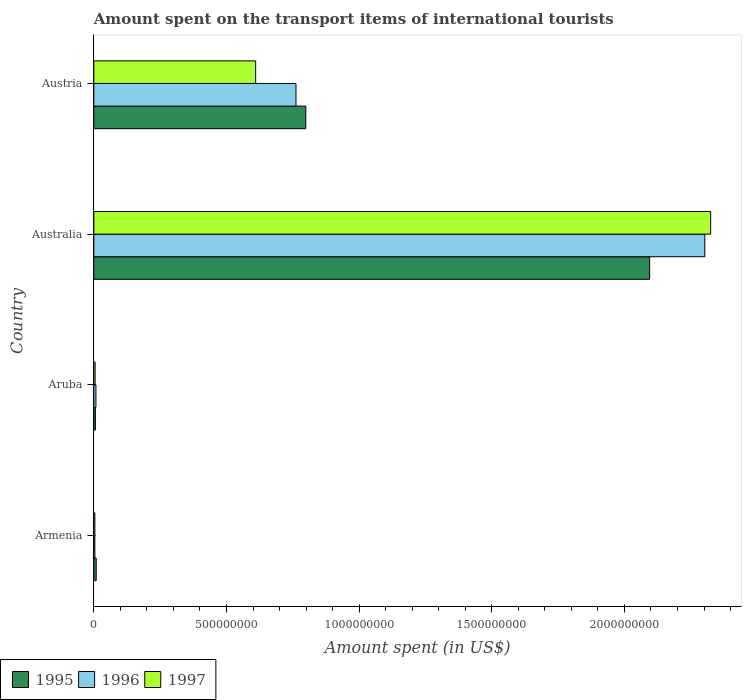How many groups of bars are there?
Keep it short and to the point. 4. Are the number of bars per tick equal to the number of legend labels?
Offer a very short reply. Yes. How many bars are there on the 1st tick from the top?
Provide a succinct answer. 3. How many bars are there on the 3rd tick from the bottom?
Offer a terse response. 3. What is the amount spent on the transport items of international tourists in 1995 in Armenia?
Offer a terse response. 9.00e+06. Across all countries, what is the maximum amount spent on the transport items of international tourists in 1995?
Provide a short and direct response. 2.10e+09. In which country was the amount spent on the transport items of international tourists in 1995 minimum?
Provide a succinct answer. Aruba. What is the total amount spent on the transport items of international tourists in 1997 in the graph?
Ensure brevity in your answer.  2.94e+09. What is the difference between the amount spent on the transport items of international tourists in 1996 in Armenia and that in Australia?
Your response must be concise. -2.30e+09. What is the difference between the amount spent on the transport items of international tourists in 1995 in Armenia and the amount spent on the transport items of international tourists in 1997 in Australia?
Offer a terse response. -2.32e+09. What is the average amount spent on the transport items of international tourists in 1995 per country?
Keep it short and to the point. 7.27e+08. What is the difference between the amount spent on the transport items of international tourists in 1997 and amount spent on the transport items of international tourists in 1995 in Austria?
Provide a short and direct response. -1.89e+08. What is the ratio of the amount spent on the transport items of international tourists in 1996 in Armenia to that in Austria?
Provide a succinct answer. 0.01. Is the amount spent on the transport items of international tourists in 1996 in Armenia less than that in Aruba?
Your answer should be compact. Yes. Is the difference between the amount spent on the transport items of international tourists in 1997 in Aruba and Austria greater than the difference between the amount spent on the transport items of international tourists in 1995 in Aruba and Austria?
Keep it short and to the point. Yes. What is the difference between the highest and the second highest amount spent on the transport items of international tourists in 1996?
Keep it short and to the point. 1.54e+09. What is the difference between the highest and the lowest amount spent on the transport items of international tourists in 1997?
Make the answer very short. 2.32e+09. In how many countries, is the amount spent on the transport items of international tourists in 1995 greater than the average amount spent on the transport items of international tourists in 1995 taken over all countries?
Ensure brevity in your answer.  2. Is the sum of the amount spent on the transport items of international tourists in 1996 in Armenia and Australia greater than the maximum amount spent on the transport items of international tourists in 1995 across all countries?
Keep it short and to the point. Yes. How many bars are there?
Offer a terse response. 12. How many countries are there in the graph?
Keep it short and to the point. 4. What is the difference between two consecutive major ticks on the X-axis?
Your answer should be compact. 5.00e+08. Does the graph contain any zero values?
Keep it short and to the point. No. Does the graph contain grids?
Keep it short and to the point. No. What is the title of the graph?
Keep it short and to the point. Amount spent on the transport items of international tourists. What is the label or title of the X-axis?
Your answer should be compact. Amount spent (in US$). What is the Amount spent (in US$) of 1995 in Armenia?
Your answer should be very brief. 9.00e+06. What is the Amount spent (in US$) in 1996 in Armenia?
Your answer should be very brief. 4.00e+06. What is the Amount spent (in US$) in 1997 in Aruba?
Provide a succinct answer. 5.00e+06. What is the Amount spent (in US$) of 1995 in Australia?
Offer a very short reply. 2.10e+09. What is the Amount spent (in US$) in 1996 in Australia?
Your answer should be very brief. 2.30e+09. What is the Amount spent (in US$) in 1997 in Australia?
Make the answer very short. 2.32e+09. What is the Amount spent (in US$) of 1995 in Austria?
Offer a terse response. 7.99e+08. What is the Amount spent (in US$) of 1996 in Austria?
Your response must be concise. 7.62e+08. What is the Amount spent (in US$) in 1997 in Austria?
Keep it short and to the point. 6.10e+08. Across all countries, what is the maximum Amount spent (in US$) of 1995?
Offer a terse response. 2.10e+09. Across all countries, what is the maximum Amount spent (in US$) of 1996?
Provide a short and direct response. 2.30e+09. Across all countries, what is the maximum Amount spent (in US$) of 1997?
Provide a succinct answer. 2.32e+09. Across all countries, what is the minimum Amount spent (in US$) of 1995?
Offer a terse response. 6.00e+06. Across all countries, what is the minimum Amount spent (in US$) in 1996?
Keep it short and to the point. 4.00e+06. What is the total Amount spent (in US$) in 1995 in the graph?
Provide a succinct answer. 2.91e+09. What is the total Amount spent (in US$) in 1996 in the graph?
Your answer should be very brief. 3.08e+09. What is the total Amount spent (in US$) in 1997 in the graph?
Keep it short and to the point. 2.94e+09. What is the difference between the Amount spent (in US$) of 1995 in Armenia and that in Australia?
Ensure brevity in your answer.  -2.09e+09. What is the difference between the Amount spent (in US$) of 1996 in Armenia and that in Australia?
Your response must be concise. -2.30e+09. What is the difference between the Amount spent (in US$) in 1997 in Armenia and that in Australia?
Your response must be concise. -2.32e+09. What is the difference between the Amount spent (in US$) of 1995 in Armenia and that in Austria?
Provide a short and direct response. -7.90e+08. What is the difference between the Amount spent (in US$) in 1996 in Armenia and that in Austria?
Make the answer very short. -7.58e+08. What is the difference between the Amount spent (in US$) in 1997 in Armenia and that in Austria?
Your answer should be compact. -6.06e+08. What is the difference between the Amount spent (in US$) of 1995 in Aruba and that in Australia?
Your answer should be very brief. -2.09e+09. What is the difference between the Amount spent (in US$) of 1996 in Aruba and that in Australia?
Give a very brief answer. -2.30e+09. What is the difference between the Amount spent (in US$) in 1997 in Aruba and that in Australia?
Provide a short and direct response. -2.32e+09. What is the difference between the Amount spent (in US$) in 1995 in Aruba and that in Austria?
Give a very brief answer. -7.93e+08. What is the difference between the Amount spent (in US$) in 1996 in Aruba and that in Austria?
Provide a succinct answer. -7.54e+08. What is the difference between the Amount spent (in US$) of 1997 in Aruba and that in Austria?
Give a very brief answer. -6.05e+08. What is the difference between the Amount spent (in US$) in 1995 in Australia and that in Austria?
Offer a terse response. 1.30e+09. What is the difference between the Amount spent (in US$) in 1996 in Australia and that in Austria?
Offer a terse response. 1.54e+09. What is the difference between the Amount spent (in US$) of 1997 in Australia and that in Austria?
Keep it short and to the point. 1.72e+09. What is the difference between the Amount spent (in US$) in 1995 in Armenia and the Amount spent (in US$) in 1997 in Aruba?
Give a very brief answer. 4.00e+06. What is the difference between the Amount spent (in US$) in 1995 in Armenia and the Amount spent (in US$) in 1996 in Australia?
Offer a terse response. -2.29e+09. What is the difference between the Amount spent (in US$) in 1995 in Armenia and the Amount spent (in US$) in 1997 in Australia?
Ensure brevity in your answer.  -2.32e+09. What is the difference between the Amount spent (in US$) of 1996 in Armenia and the Amount spent (in US$) of 1997 in Australia?
Ensure brevity in your answer.  -2.32e+09. What is the difference between the Amount spent (in US$) of 1995 in Armenia and the Amount spent (in US$) of 1996 in Austria?
Your answer should be very brief. -7.53e+08. What is the difference between the Amount spent (in US$) in 1995 in Armenia and the Amount spent (in US$) in 1997 in Austria?
Your answer should be compact. -6.01e+08. What is the difference between the Amount spent (in US$) of 1996 in Armenia and the Amount spent (in US$) of 1997 in Austria?
Keep it short and to the point. -6.06e+08. What is the difference between the Amount spent (in US$) of 1995 in Aruba and the Amount spent (in US$) of 1996 in Australia?
Your answer should be compact. -2.30e+09. What is the difference between the Amount spent (in US$) in 1995 in Aruba and the Amount spent (in US$) in 1997 in Australia?
Keep it short and to the point. -2.32e+09. What is the difference between the Amount spent (in US$) in 1996 in Aruba and the Amount spent (in US$) in 1997 in Australia?
Give a very brief answer. -2.32e+09. What is the difference between the Amount spent (in US$) of 1995 in Aruba and the Amount spent (in US$) of 1996 in Austria?
Keep it short and to the point. -7.56e+08. What is the difference between the Amount spent (in US$) in 1995 in Aruba and the Amount spent (in US$) in 1997 in Austria?
Keep it short and to the point. -6.04e+08. What is the difference between the Amount spent (in US$) of 1996 in Aruba and the Amount spent (in US$) of 1997 in Austria?
Provide a short and direct response. -6.02e+08. What is the difference between the Amount spent (in US$) in 1995 in Australia and the Amount spent (in US$) in 1996 in Austria?
Make the answer very short. 1.33e+09. What is the difference between the Amount spent (in US$) of 1995 in Australia and the Amount spent (in US$) of 1997 in Austria?
Make the answer very short. 1.48e+09. What is the difference between the Amount spent (in US$) in 1996 in Australia and the Amount spent (in US$) in 1997 in Austria?
Your answer should be very brief. 1.69e+09. What is the average Amount spent (in US$) in 1995 per country?
Your response must be concise. 7.27e+08. What is the average Amount spent (in US$) of 1996 per country?
Your answer should be very brief. 7.69e+08. What is the average Amount spent (in US$) in 1997 per country?
Offer a very short reply. 7.36e+08. What is the difference between the Amount spent (in US$) in 1995 and Amount spent (in US$) in 1996 in Aruba?
Your answer should be very brief. -2.00e+06. What is the difference between the Amount spent (in US$) in 1996 and Amount spent (in US$) in 1997 in Aruba?
Your answer should be compact. 3.00e+06. What is the difference between the Amount spent (in US$) in 1995 and Amount spent (in US$) in 1996 in Australia?
Your answer should be very brief. -2.08e+08. What is the difference between the Amount spent (in US$) of 1995 and Amount spent (in US$) of 1997 in Australia?
Keep it short and to the point. -2.30e+08. What is the difference between the Amount spent (in US$) of 1996 and Amount spent (in US$) of 1997 in Australia?
Provide a short and direct response. -2.20e+07. What is the difference between the Amount spent (in US$) in 1995 and Amount spent (in US$) in 1996 in Austria?
Provide a succinct answer. 3.70e+07. What is the difference between the Amount spent (in US$) of 1995 and Amount spent (in US$) of 1997 in Austria?
Provide a succinct answer. 1.89e+08. What is the difference between the Amount spent (in US$) of 1996 and Amount spent (in US$) of 1997 in Austria?
Keep it short and to the point. 1.52e+08. What is the ratio of the Amount spent (in US$) of 1995 in Armenia to that in Aruba?
Keep it short and to the point. 1.5. What is the ratio of the Amount spent (in US$) in 1996 in Armenia to that in Aruba?
Provide a succinct answer. 0.5. What is the ratio of the Amount spent (in US$) in 1997 in Armenia to that in Aruba?
Make the answer very short. 0.8. What is the ratio of the Amount spent (in US$) in 1995 in Armenia to that in Australia?
Your answer should be compact. 0. What is the ratio of the Amount spent (in US$) of 1996 in Armenia to that in Australia?
Provide a short and direct response. 0. What is the ratio of the Amount spent (in US$) in 1997 in Armenia to that in Australia?
Give a very brief answer. 0. What is the ratio of the Amount spent (in US$) in 1995 in Armenia to that in Austria?
Provide a short and direct response. 0.01. What is the ratio of the Amount spent (in US$) in 1996 in Armenia to that in Austria?
Your answer should be compact. 0.01. What is the ratio of the Amount spent (in US$) of 1997 in Armenia to that in Austria?
Your response must be concise. 0.01. What is the ratio of the Amount spent (in US$) in 1995 in Aruba to that in Australia?
Your response must be concise. 0. What is the ratio of the Amount spent (in US$) in 1996 in Aruba to that in Australia?
Your response must be concise. 0. What is the ratio of the Amount spent (in US$) in 1997 in Aruba to that in Australia?
Ensure brevity in your answer.  0. What is the ratio of the Amount spent (in US$) of 1995 in Aruba to that in Austria?
Keep it short and to the point. 0.01. What is the ratio of the Amount spent (in US$) in 1996 in Aruba to that in Austria?
Provide a succinct answer. 0.01. What is the ratio of the Amount spent (in US$) in 1997 in Aruba to that in Austria?
Make the answer very short. 0.01. What is the ratio of the Amount spent (in US$) of 1995 in Australia to that in Austria?
Make the answer very short. 2.62. What is the ratio of the Amount spent (in US$) in 1996 in Australia to that in Austria?
Your answer should be very brief. 3.02. What is the ratio of the Amount spent (in US$) of 1997 in Australia to that in Austria?
Your answer should be compact. 3.81. What is the difference between the highest and the second highest Amount spent (in US$) of 1995?
Offer a terse response. 1.30e+09. What is the difference between the highest and the second highest Amount spent (in US$) in 1996?
Make the answer very short. 1.54e+09. What is the difference between the highest and the second highest Amount spent (in US$) of 1997?
Keep it short and to the point. 1.72e+09. What is the difference between the highest and the lowest Amount spent (in US$) of 1995?
Offer a very short reply. 2.09e+09. What is the difference between the highest and the lowest Amount spent (in US$) in 1996?
Provide a succinct answer. 2.30e+09. What is the difference between the highest and the lowest Amount spent (in US$) of 1997?
Your answer should be very brief. 2.32e+09. 